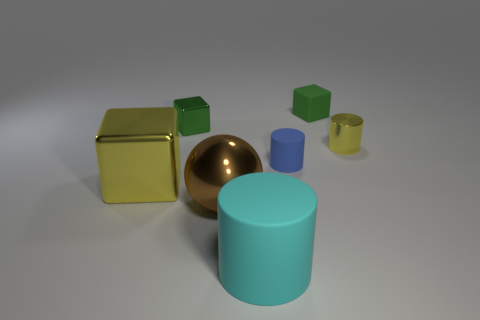If the large green cube were to be moved to the opposite side of the yellow cylinder, would it still be the largest object displayed? Yes, if the large green cube were moved to the opposite side of the yellow cylinder, it would still be the largest object in terms of height and width when compared to the other shapes present in the image. 